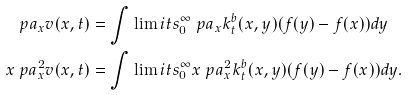<formula> <loc_0><loc_0><loc_500><loc_500>\ p a _ { x } v ( x , t ) & = \int \lim i t s _ { 0 } ^ { \infty } \ p a _ { x } k ^ { b } _ { t } ( x , y ) ( f ( y ) - f ( x ) ) d y \\ x \ p a ^ { 2 } _ { x } v ( x , t ) & = \int \lim i t s _ { 0 } ^ { \infty } x \ p a _ { x } ^ { 2 } k ^ { b } _ { t } ( x , y ) ( f ( y ) - f ( x ) ) d y .</formula> 